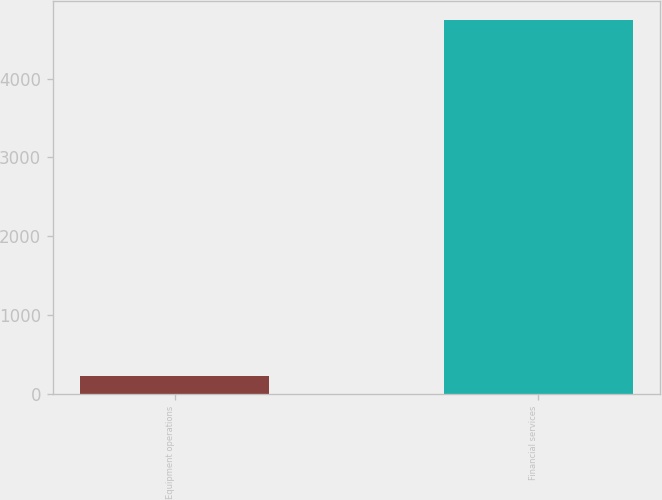<chart> <loc_0><loc_0><loc_500><loc_500><bar_chart><fcel>Equipment operations<fcel>Financial services<nl><fcel>233<fcel>4743<nl></chart> 